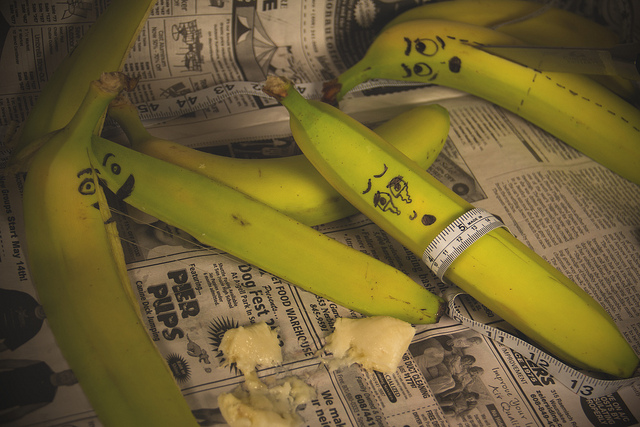Extract all visible text content from this image. PUPS WAREHOUSE FOOD 13 12 608/441 nei We Fest STAR1 4/3 